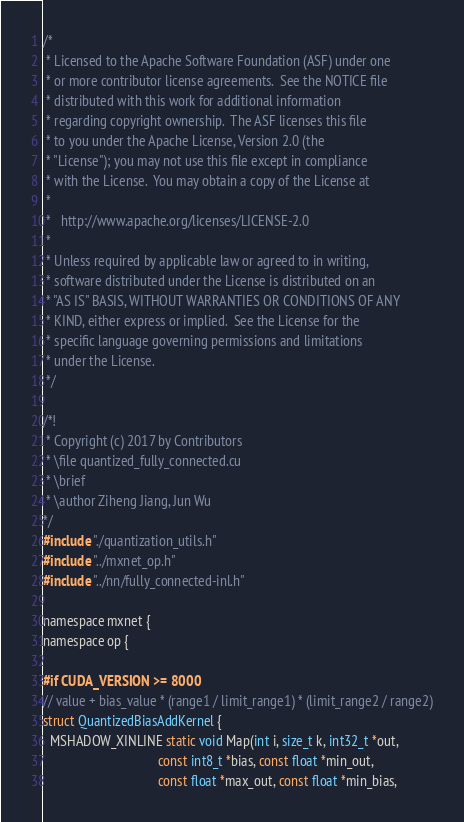<code> <loc_0><loc_0><loc_500><loc_500><_Cuda_>/*
 * Licensed to the Apache Software Foundation (ASF) under one
 * or more contributor license agreements.  See the NOTICE file
 * distributed with this work for additional information
 * regarding copyright ownership.  The ASF licenses this file
 * to you under the Apache License, Version 2.0 (the
 * "License"); you may not use this file except in compliance
 * with the License.  You may obtain a copy of the License at
 *
 *   http://www.apache.org/licenses/LICENSE-2.0
 *
 * Unless required by applicable law or agreed to in writing,
 * software distributed under the License is distributed on an
 * "AS IS" BASIS, WITHOUT WARRANTIES OR CONDITIONS OF ANY
 * KIND, either express or implied.  See the License for the
 * specific language governing permissions and limitations
 * under the License.
 */

/*!
 * Copyright (c) 2017 by Contributors
 * \file quantized_fully_connected.cu
 * \brief
 * \author Ziheng Jiang, Jun Wu
*/
#include "./quantization_utils.h"
#include "../mxnet_op.h"
#include "../nn/fully_connected-inl.h"

namespace mxnet {
namespace op {

#if CUDA_VERSION >= 8000
// value + bias_value * (range1 / limit_range1) * (limit_range2 / range2)
struct QuantizedBiasAddKernel {
  MSHADOW_XINLINE static void Map(int i, size_t k, int32_t *out,
                                  const int8_t *bias, const float *min_out,
                                  const float *max_out, const float *min_bias,</code> 